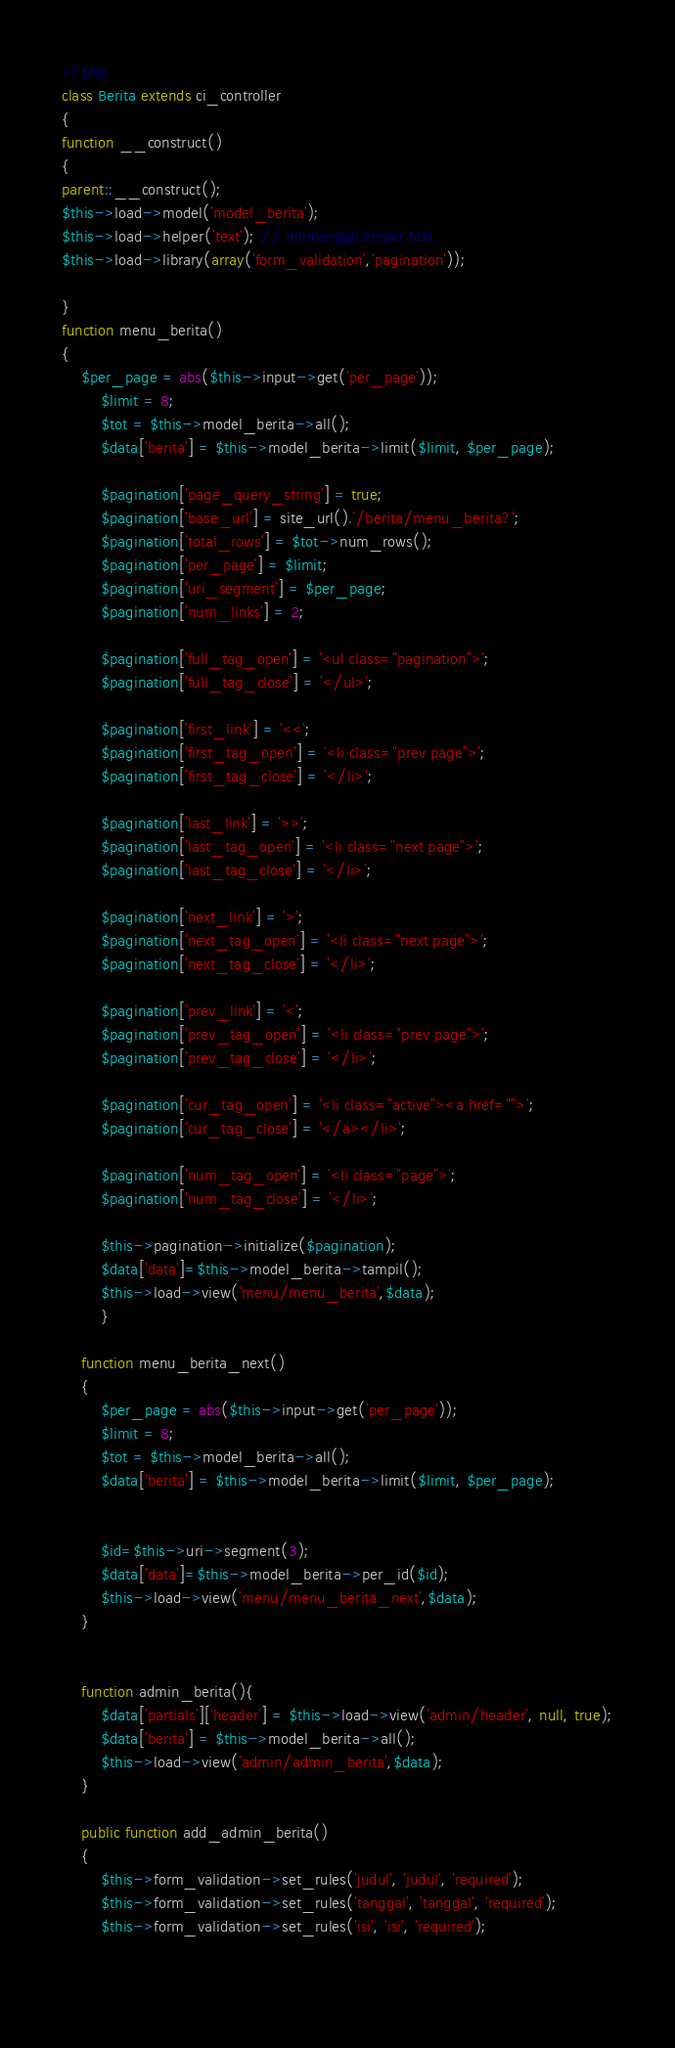<code> <loc_0><loc_0><loc_500><loc_500><_PHP_><?php
class Berita extends ci_controller
{
function __construct()
{
parent::__construct();
$this->load->model('model_berita');
$this->load->helper('text'); // memanggil helper text
$this->load->library(array('form_validation','pagination'));
		
}
function menu_berita()
{
	$per_page = abs($this->input->get('per_page'));
		$limit = 8;
		$tot = $this->model_berita->all();
		$data['berita'] = $this->model_berita->limit($limit, $per_page);

		$pagination['page_query_string'] = true;
		$pagination['base_url'] = site_url().'/berita/menu_berita?';
		$pagination['total_rows'] = $tot->num_rows();
		$pagination['per_page'] = $limit;
		$pagination['uri_segment'] = $per_page;
		$pagination['num_links'] = 2;

		$pagination['full_tag_open'] = '<ul class="pagination">';
		$pagination['full_tag_close'] = '</ul>';

		$pagination['first_link'] = '<<';
		$pagination['first_tag_open'] = '<li class="prev page">';
		$pagination['first_tag_close'] = '</li>';

		$pagination['last_link'] = '>>';
		$pagination['last_tag_open'] = '<li class="next page">';
		$pagination['last_tag_close'] = '</li>';

		$pagination['next_link'] = '>';
		$pagination['next_tag_open'] = '<li class="next page">';
		$pagination['next_tag_close'] = '</li>';

		$pagination['prev_link'] = '<';
		$pagination['prev_tag_open'] = '<li class="prev page">';
		$pagination['prev_tag_close'] = '</li>';

		$pagination['cur_tag_open'] = '<li class="active"><a href="">';
		$pagination['cur_tag_close'] = '</a></li>';

		$pagination['num_tag_open'] = '<li class="page">';
		$pagination['num_tag_close'] = '</li>';

		$this->pagination->initialize($pagination);
		$data['data']=$this->model_berita->tampil();
		$this->load->view('menu/menu_berita',$data);
		}

	function menu_berita_next()
	{
		$per_page = abs($this->input->get('per_page'));
		$limit = 8;
		$tot = $this->model_berita->all();
		$data['berita'] = $this->model_berita->limit($limit, $per_page);
	
		
		$id=$this->uri->segment(3);
		$data['data']=$this->model_berita->per_id($id);
		$this->load->view('menu/menu_berita_next',$data);
	}
	

	function admin_berita(){
		$data['partials']['header'] = $this->load->view('admin/header', null, true);
		$data['berita'] = $this->model_berita->all();
		$this->load->view('admin/admin_berita',$data);
	}
	
	public function add_admin_berita()
	{
		$this->form_validation->set_rules('judul', 'judul', 'required');
		$this->form_validation->set_rules('tanggal', 'tanggal', 'required');
		$this->form_validation->set_rules('isi', 'isi', 'required');
		
		</code> 